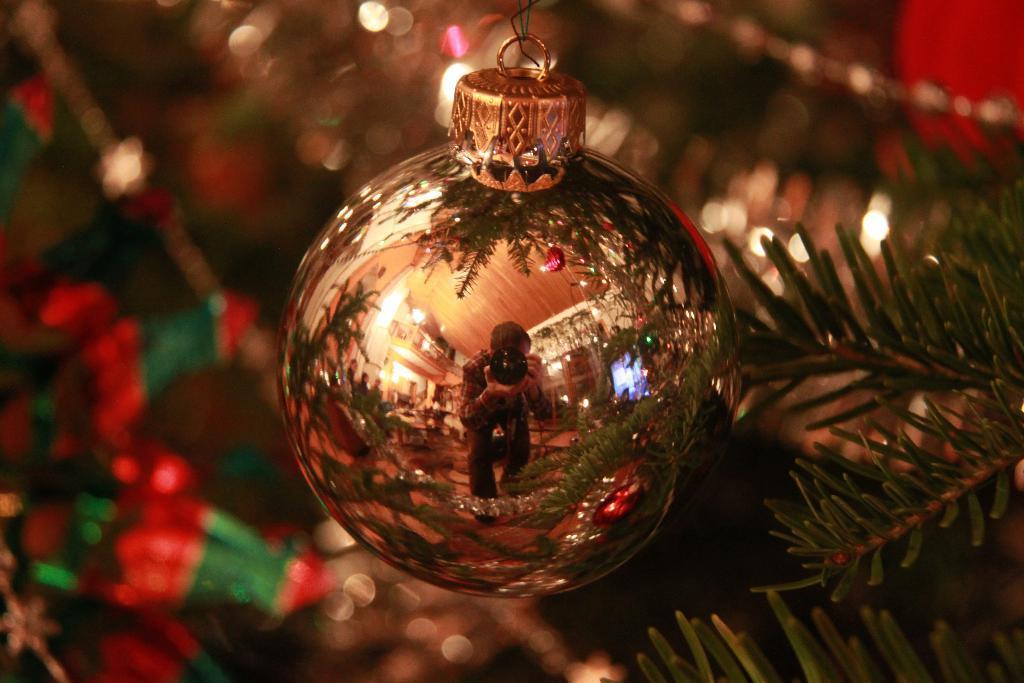In one or two sentences, can you explain what this image depicts? In the foreground of this image, there is a decorative ball to the x mas tree and in the reflection in the ball, there is a man holding camera and in the background, there is a room. 